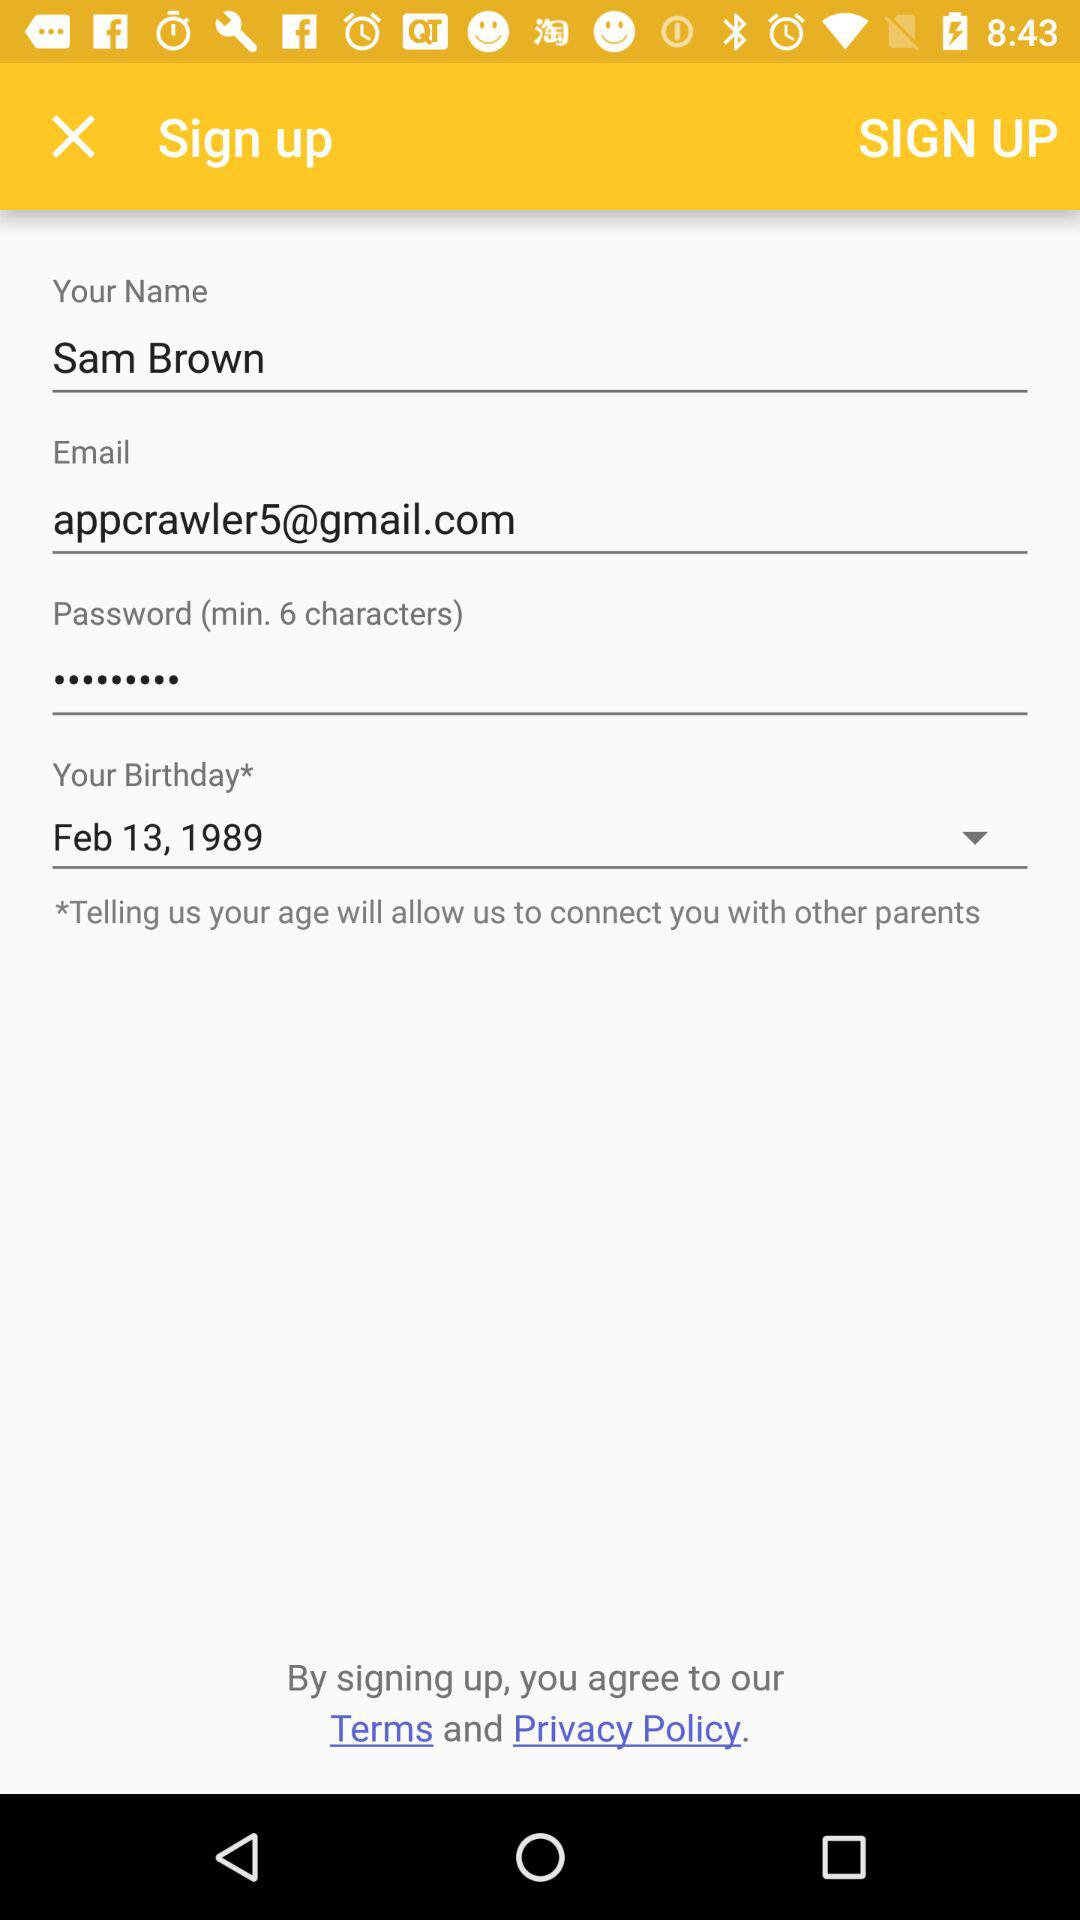What is the email address? The email address is appcrawler5@gmail.com. 